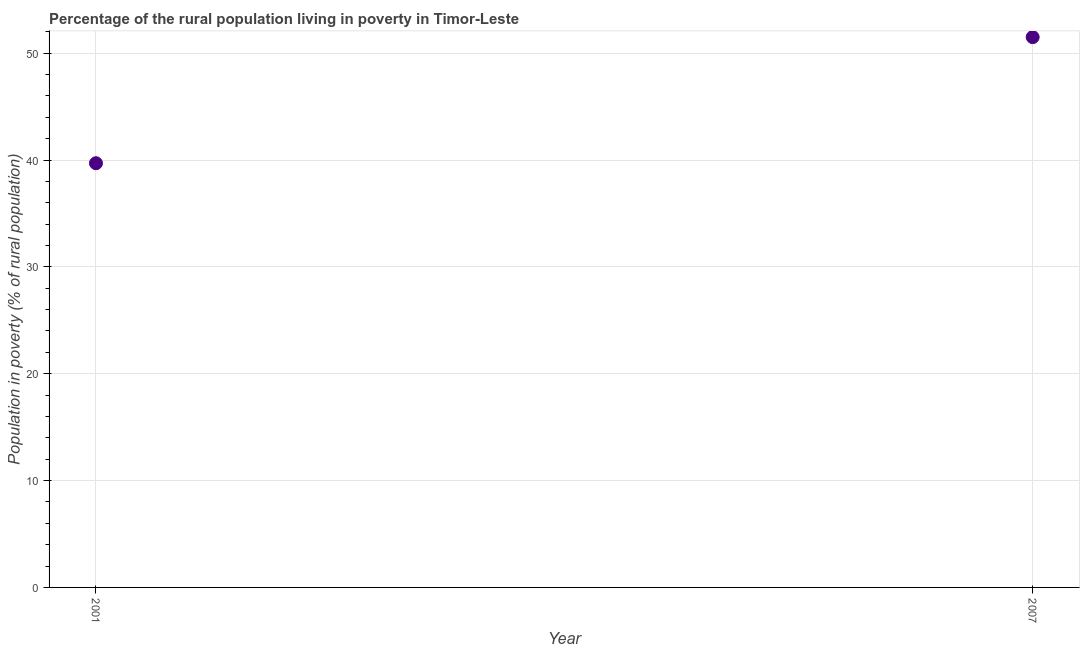What is the percentage of rural population living below poverty line in 2001?
Your answer should be very brief. 39.7. Across all years, what is the maximum percentage of rural population living below poverty line?
Ensure brevity in your answer.  51.5. Across all years, what is the minimum percentage of rural population living below poverty line?
Your answer should be compact. 39.7. In which year was the percentage of rural population living below poverty line maximum?
Give a very brief answer. 2007. What is the sum of the percentage of rural population living below poverty line?
Offer a terse response. 91.2. What is the difference between the percentage of rural population living below poverty line in 2001 and 2007?
Your answer should be compact. -11.8. What is the average percentage of rural population living below poverty line per year?
Your answer should be compact. 45.6. What is the median percentage of rural population living below poverty line?
Make the answer very short. 45.6. In how many years, is the percentage of rural population living below poverty line greater than 46 %?
Offer a very short reply. 1. What is the ratio of the percentage of rural population living below poverty line in 2001 to that in 2007?
Make the answer very short. 0.77. Is the percentage of rural population living below poverty line in 2001 less than that in 2007?
Your answer should be very brief. Yes. How many dotlines are there?
Make the answer very short. 1. What is the difference between two consecutive major ticks on the Y-axis?
Ensure brevity in your answer.  10. Does the graph contain any zero values?
Make the answer very short. No. What is the title of the graph?
Give a very brief answer. Percentage of the rural population living in poverty in Timor-Leste. What is the label or title of the Y-axis?
Provide a short and direct response. Population in poverty (% of rural population). What is the Population in poverty (% of rural population) in 2001?
Keep it short and to the point. 39.7. What is the Population in poverty (% of rural population) in 2007?
Make the answer very short. 51.5. What is the difference between the Population in poverty (% of rural population) in 2001 and 2007?
Make the answer very short. -11.8. What is the ratio of the Population in poverty (% of rural population) in 2001 to that in 2007?
Ensure brevity in your answer.  0.77. 